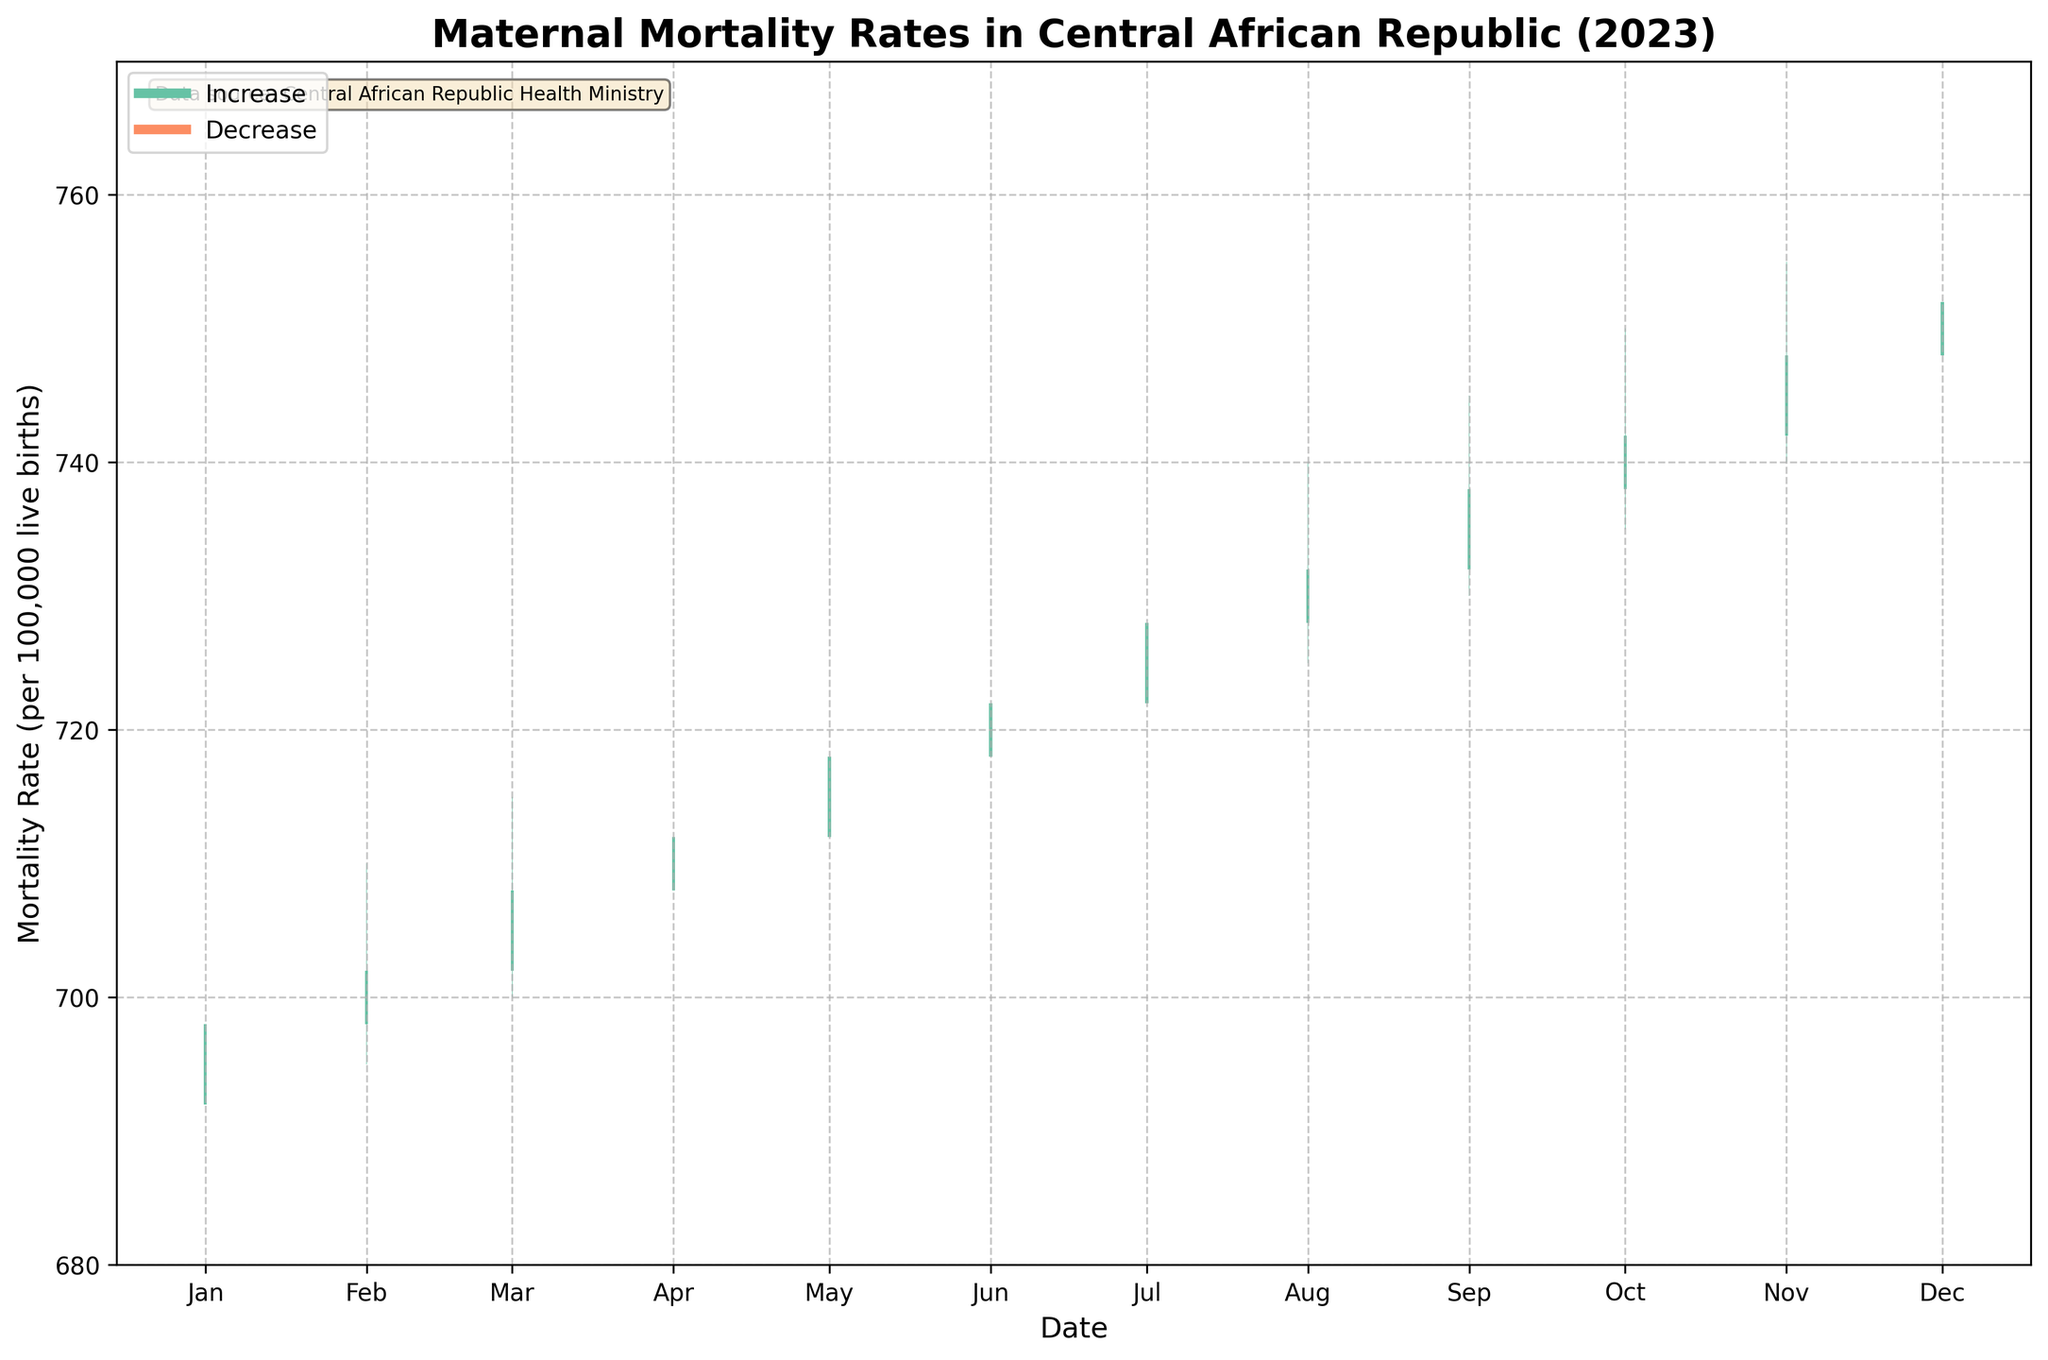What is the title of the figure? The title of the figure is prominently displayed at the top and reads: "Maternal Mortality Rates in Central African Republic (2023)".
Answer: Maternal Mortality Rates in Central African Republic (2023) What does it mean when the bars are colored green? The green color on the bars indicates that the closing maternal mortality rate is higher than the opening rate for that month.
Answer: The rate increased How many months show a decrease in maternal mortality rates? The red bars indicate a decrease in maternal mortality rates. By counting the red bars, we see that there are no months with a decrease in rates within 2023.
Answer: None Which month had the highest maternal mortality rate? To find the highest maternal mortality rate, we look for the peak of the highest bar, including the topmost point of the green or red segments. November's peak reaches 755, the highest for the year.
Answer: November What are the minimum and maximum maternal mortality rates in April? April's low point (bottom of the bar) is 705, and its high point (top of the bar) is 720.
Answer: 705 and 720 Describe the overall trend in maternal mortality rates throughout the year. The maternal mortality rates show an overall increasing trend from January to December, as indicated by the positive color change in each month's bar segment (green, indicating increases).
Answer: Increasing trend In which month did the maternal mortality rate change the least and by how much? To find the smallest change, look for the smallest bar height difference between the high and low. In July, the range is smallest from 720 to 735, a difference of 15.
Answer: July, 15 What is the average closing maternal mortality rate over the entire year? Summing the closing rates: 698 + 702 + 708 + 712 + 718 + 722 + 728 + 732 + 738 + 742 + 748 + 752 = 8702. Dividing by 12 (12 months): 8702 / 12 = 725.17.
Answer: 725.17 How did the maternal mortality rate change from September to October? Comparing the closing rates: September closes at 738 and October closes at 742. The change is: 742 - 738 = 4.
Answer: Increased by 4 Which month had the smallest opening maternal mortality rate? January has the smallest opening maternal mortality rate, starting at 692.
Answer: January 